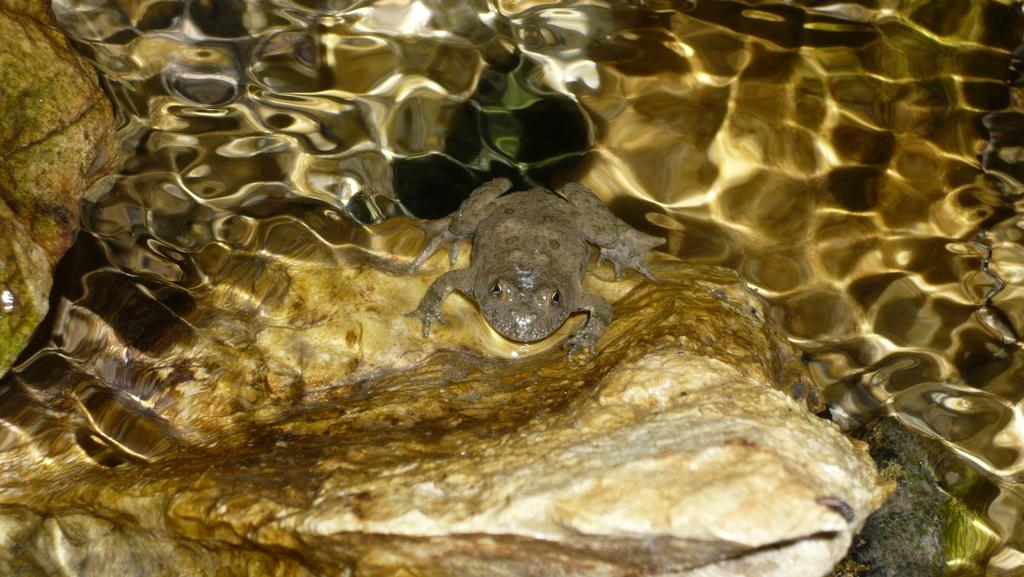What type of natural elements can be seen in the image? There are rocks in the image. What type of animal is present in the image? There is a frog in the image. What can be seen in the background of the image? There is water visible in the image. Where is the woman sitting in the image? There is no woman present in the image; it features rocks, a frog, and water. How many bears can be seen in the image? There are no bears present in the image. 